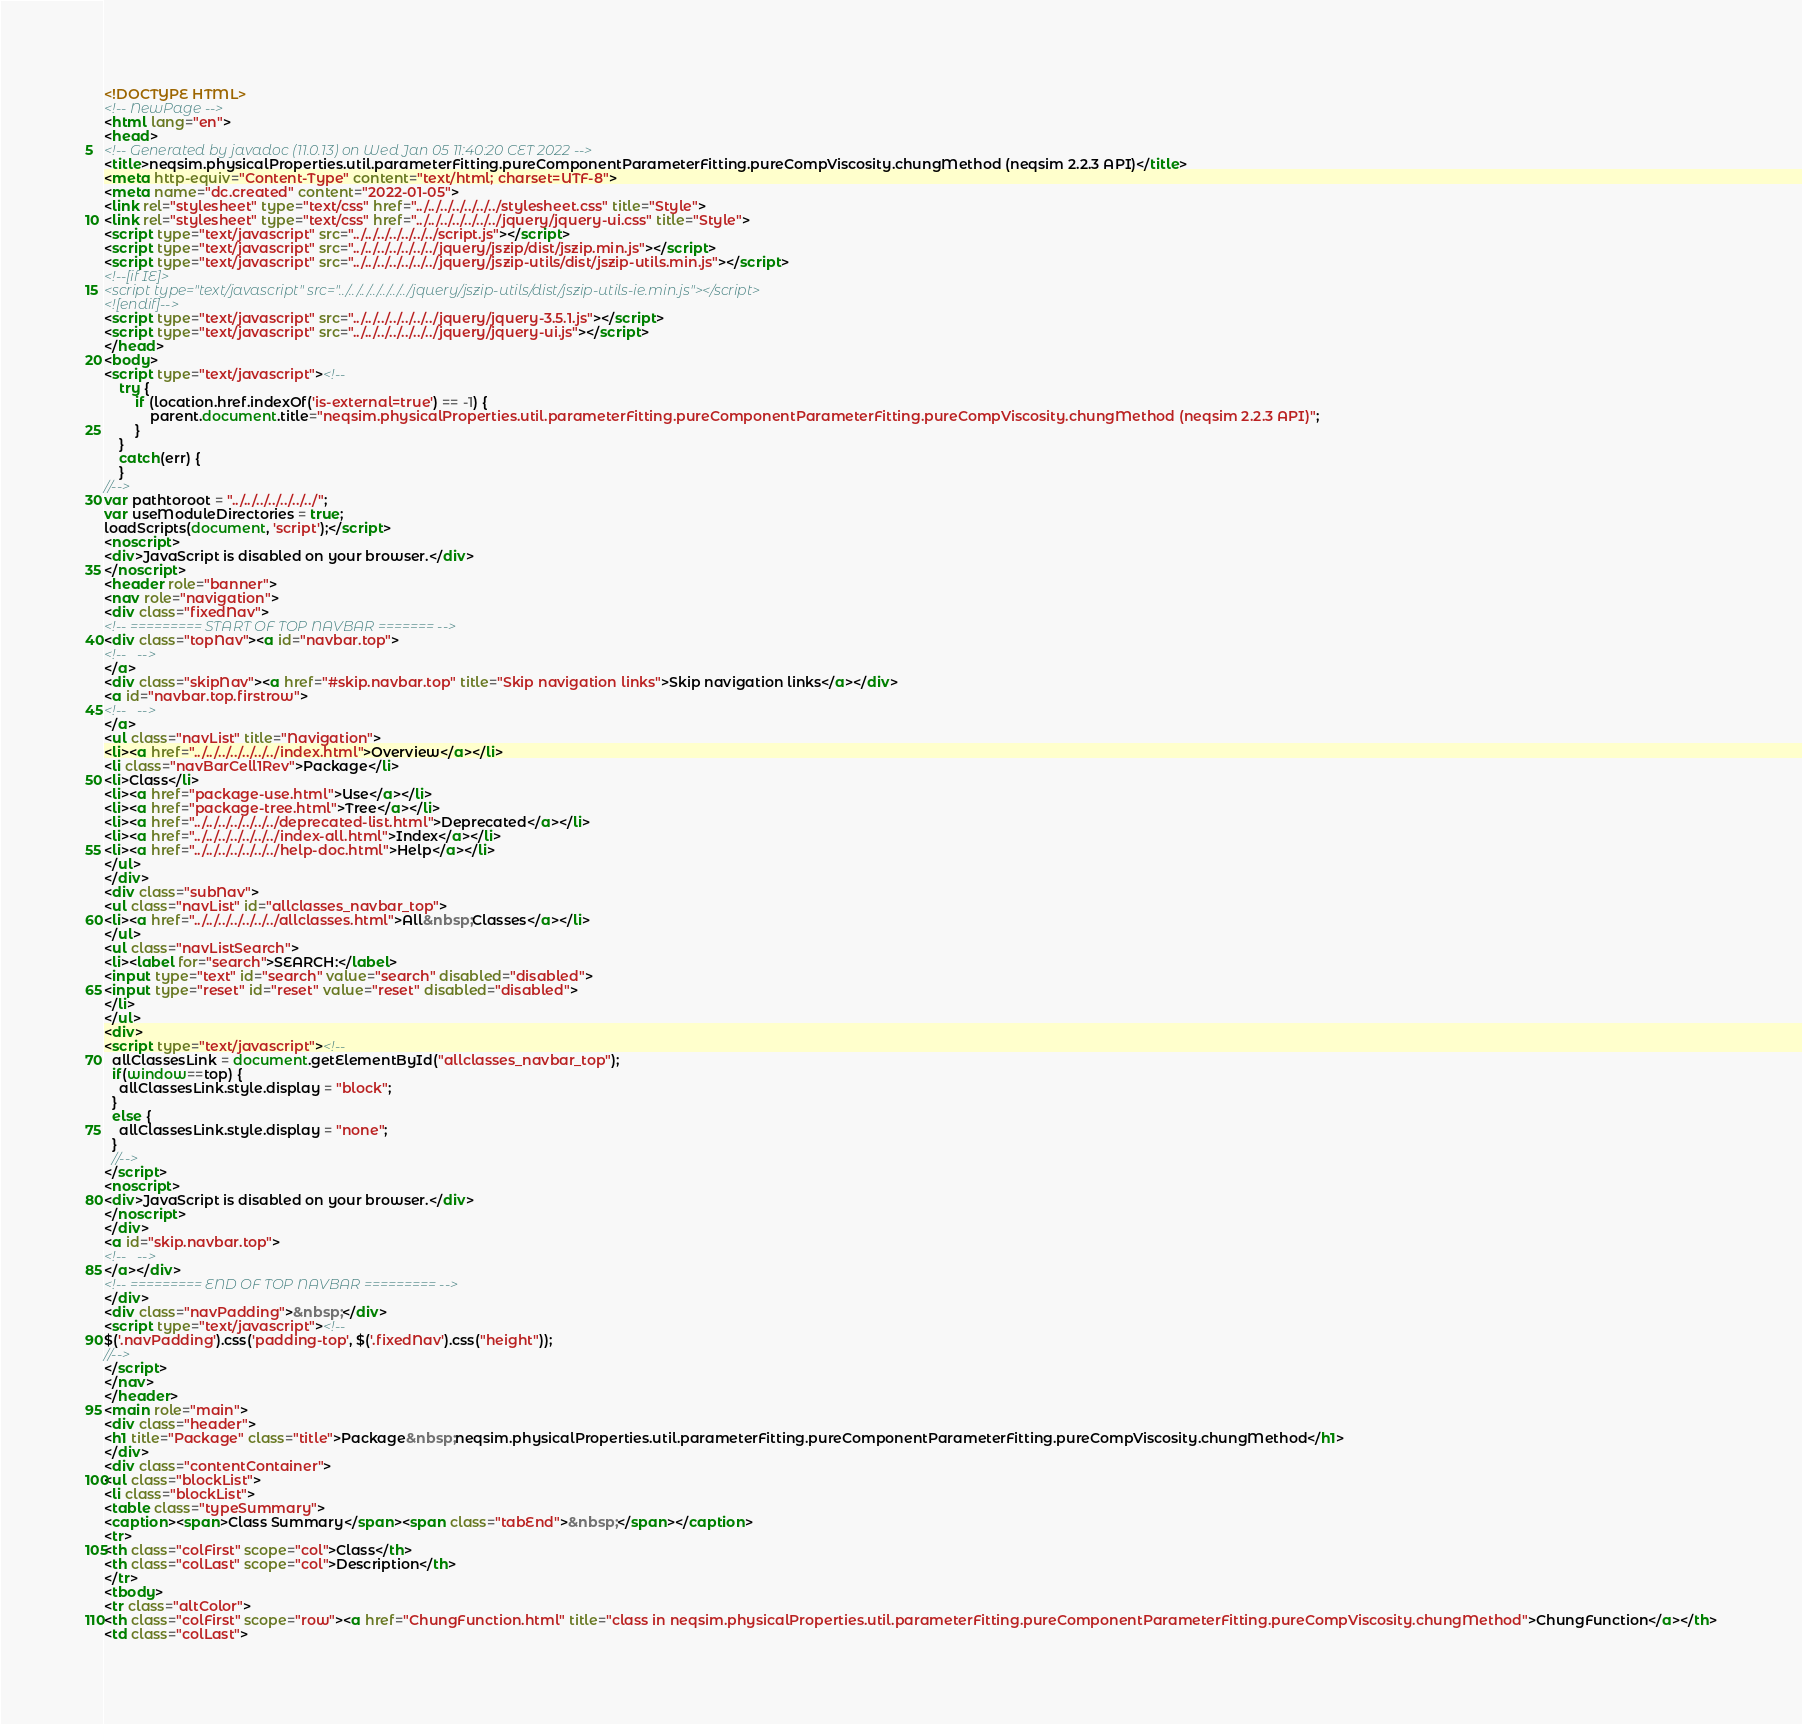<code> <loc_0><loc_0><loc_500><loc_500><_HTML_><!DOCTYPE HTML>
<!-- NewPage -->
<html lang="en">
<head>
<!-- Generated by javadoc (11.0.13) on Wed Jan 05 11:40:20 CET 2022 -->
<title>neqsim.physicalProperties.util.parameterFitting.pureComponentParameterFitting.pureCompViscosity.chungMethod (neqsim 2.2.3 API)</title>
<meta http-equiv="Content-Type" content="text/html; charset=UTF-8">
<meta name="dc.created" content="2022-01-05">
<link rel="stylesheet" type="text/css" href="../../../../../../../stylesheet.css" title="Style">
<link rel="stylesheet" type="text/css" href="../../../../../../../jquery/jquery-ui.css" title="Style">
<script type="text/javascript" src="../../../../../../../script.js"></script>
<script type="text/javascript" src="../../../../../../../jquery/jszip/dist/jszip.min.js"></script>
<script type="text/javascript" src="../../../../../../../jquery/jszip-utils/dist/jszip-utils.min.js"></script>
<!--[if IE]>
<script type="text/javascript" src="../../../../../../../jquery/jszip-utils/dist/jszip-utils-ie.min.js"></script>
<![endif]-->
<script type="text/javascript" src="../../../../../../../jquery/jquery-3.5.1.js"></script>
<script type="text/javascript" src="../../../../../../../jquery/jquery-ui.js"></script>
</head>
<body>
<script type="text/javascript"><!--
    try {
        if (location.href.indexOf('is-external=true') == -1) {
            parent.document.title="neqsim.physicalProperties.util.parameterFitting.pureComponentParameterFitting.pureCompViscosity.chungMethod (neqsim 2.2.3 API)";
        }
    }
    catch(err) {
    }
//-->
var pathtoroot = "../../../../../../../";
var useModuleDirectories = true;
loadScripts(document, 'script');</script>
<noscript>
<div>JavaScript is disabled on your browser.</div>
</noscript>
<header role="banner">
<nav role="navigation">
<div class="fixedNav">
<!-- ========= START OF TOP NAVBAR ======= -->
<div class="topNav"><a id="navbar.top">
<!--   -->
</a>
<div class="skipNav"><a href="#skip.navbar.top" title="Skip navigation links">Skip navigation links</a></div>
<a id="navbar.top.firstrow">
<!--   -->
</a>
<ul class="navList" title="Navigation">
<li><a href="../../../../../../../index.html">Overview</a></li>
<li class="navBarCell1Rev">Package</li>
<li>Class</li>
<li><a href="package-use.html">Use</a></li>
<li><a href="package-tree.html">Tree</a></li>
<li><a href="../../../../../../../deprecated-list.html">Deprecated</a></li>
<li><a href="../../../../../../../index-all.html">Index</a></li>
<li><a href="../../../../../../../help-doc.html">Help</a></li>
</ul>
</div>
<div class="subNav">
<ul class="navList" id="allclasses_navbar_top">
<li><a href="../../../../../../../allclasses.html">All&nbsp;Classes</a></li>
</ul>
<ul class="navListSearch">
<li><label for="search">SEARCH:</label>
<input type="text" id="search" value="search" disabled="disabled">
<input type="reset" id="reset" value="reset" disabled="disabled">
</li>
</ul>
<div>
<script type="text/javascript"><!--
  allClassesLink = document.getElementById("allclasses_navbar_top");
  if(window==top) {
    allClassesLink.style.display = "block";
  }
  else {
    allClassesLink.style.display = "none";
  }
  //-->
</script>
<noscript>
<div>JavaScript is disabled on your browser.</div>
</noscript>
</div>
<a id="skip.navbar.top">
<!--   -->
</a></div>
<!-- ========= END OF TOP NAVBAR ========= -->
</div>
<div class="navPadding">&nbsp;</div>
<script type="text/javascript"><!--
$('.navPadding').css('padding-top', $('.fixedNav').css("height"));
//-->
</script>
</nav>
</header>
<main role="main">
<div class="header">
<h1 title="Package" class="title">Package&nbsp;neqsim.physicalProperties.util.parameterFitting.pureComponentParameterFitting.pureCompViscosity.chungMethod</h1>
</div>
<div class="contentContainer">
<ul class="blockList">
<li class="blockList">
<table class="typeSummary">
<caption><span>Class Summary</span><span class="tabEnd">&nbsp;</span></caption>
<tr>
<th class="colFirst" scope="col">Class</th>
<th class="colLast" scope="col">Description</th>
</tr>
<tbody>
<tr class="altColor">
<th class="colFirst" scope="row"><a href="ChungFunction.html" title="class in neqsim.physicalProperties.util.parameterFitting.pureComponentParameterFitting.pureCompViscosity.chungMethod">ChungFunction</a></th>
<td class="colLast"></code> 